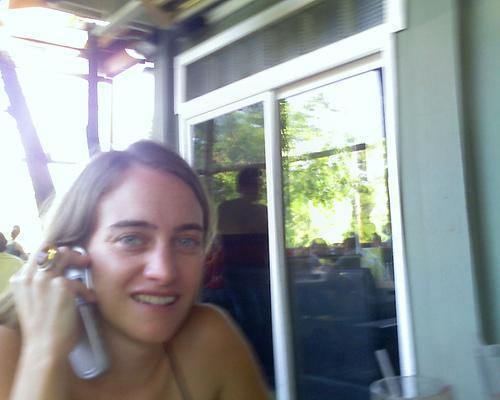How many people are reflected in the glass?
Give a very brief answer. 1. 